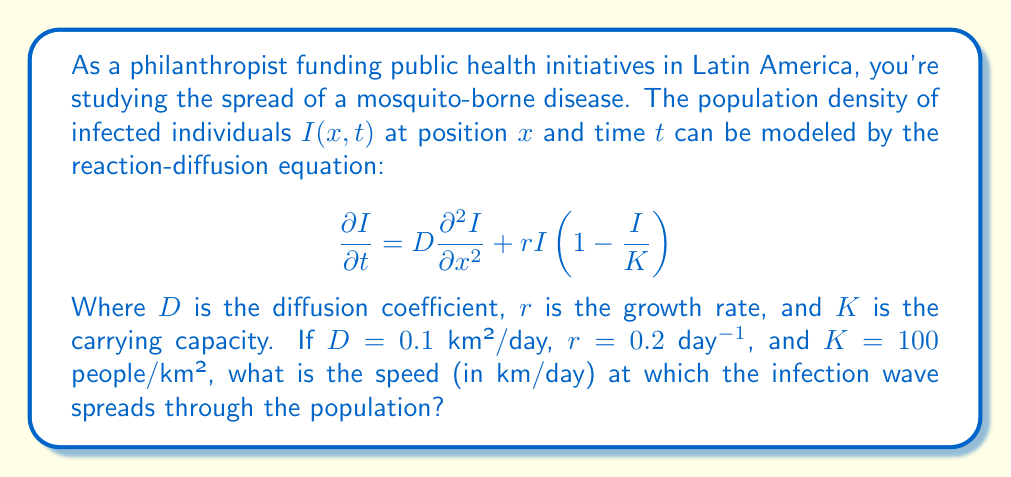What is the answer to this math problem? To solve this problem, we'll use the Fisher-Kolmogorov equation, which is a special case of the reaction-diffusion equation given in the question. The speed of the infection wave can be calculated using the following steps:

1. The Fisher-Kolmogorov equation has the form:
   $$\frac{\partial I}{\partial t} = D\frac{\partial^2 I}{\partial x^2} + rI(1-\frac{I}{K})$$

2. The speed of the wave front for this equation is given by:
   $$c = 2\sqrt{rD}$$

3. We are given:
   $D = 0.1$ km²/day
   $r = 0.2$ day⁻¹

4. Substituting these values into the equation:
   $$c = 2\sqrt{(0.2 \text{ day}^{-1})(0.1 \text{ km}^2/\text{day})}$$

5. Simplifying under the square root:
   $$c = 2\sqrt{0.02 \text{ km}^2/\text{day}^2}$$

6. Calculating the square root:
   $$c = 2(0.1414 \text{ km/day})$$

7. Final calculation:
   $$c = 0.2828 \text{ km/day}$$

8. Rounding to three decimal places:
   $$c \approx 0.283 \text{ km/day}$$
Answer: 0.283 km/day 